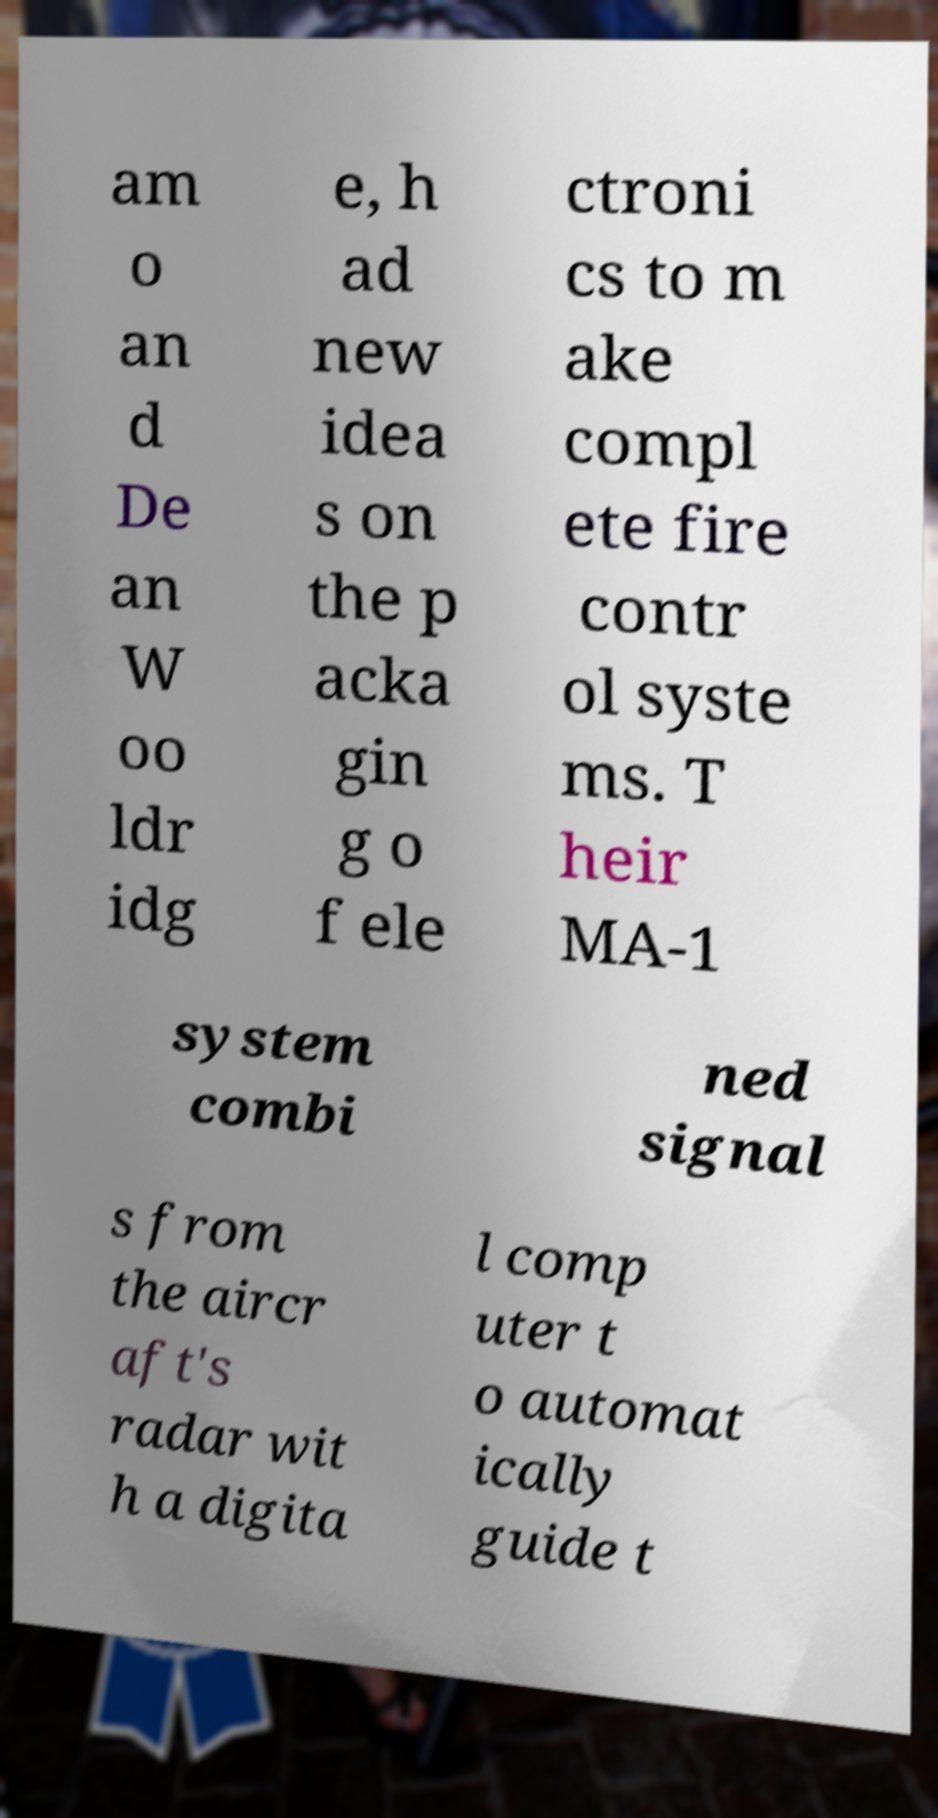What messages or text are displayed in this image? I need them in a readable, typed format. am o an d De an W oo ldr idg e, h ad new idea s on the p acka gin g o f ele ctroni cs to m ake compl ete fire contr ol syste ms. T heir MA-1 system combi ned signal s from the aircr aft's radar wit h a digita l comp uter t o automat ically guide t 